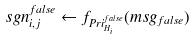Convert formula to latex. <formula><loc_0><loc_0><loc_500><loc_500>s g n _ { i , j } ^ { f a l s e } \leftarrow f _ { P r i _ { H _ { i } } ^ { f a l s e } } ( m s g _ { f a l s e } )</formula> 